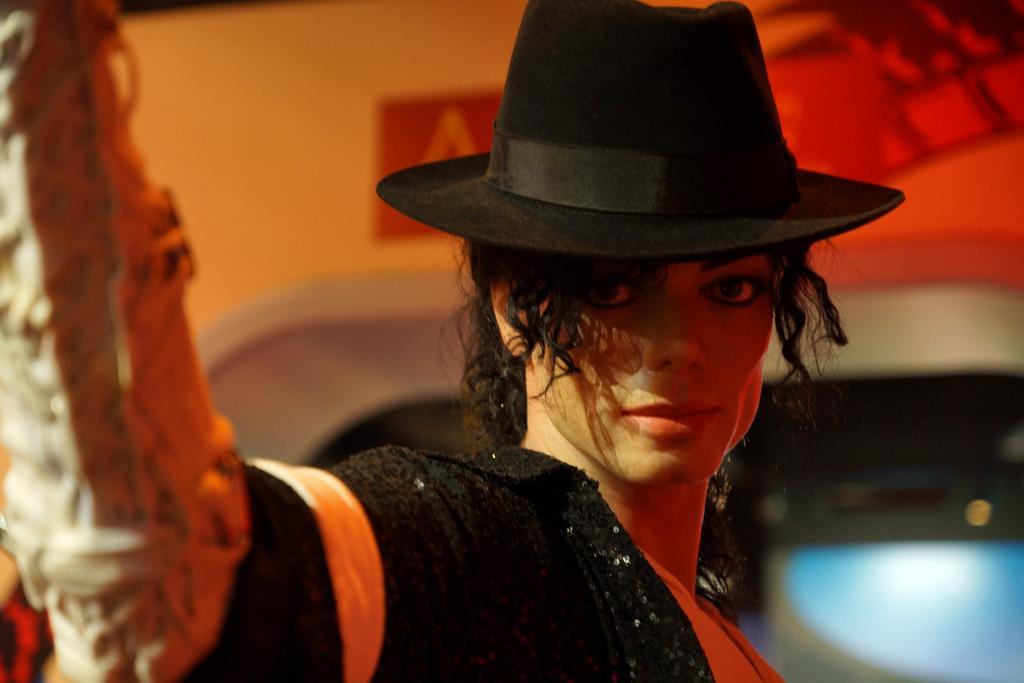Could you give a brief overview of what you see in this image? In this image there is michael jackson posing for a pic wearing hat, behind him there is a wall. 